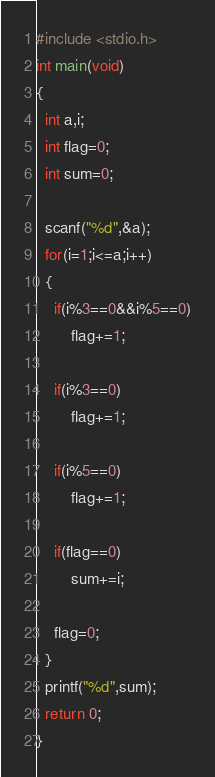<code> <loc_0><loc_0><loc_500><loc_500><_C_>#include <stdio.h>
int main(void)
{
  int a,i;
  int flag=0;
  int sum=0;
    
  scanf("%d",&a);
  for(i=1;i<=a;i++)
  {
    if(i%3==0&&i%5==0)
        flag+=1;
      
    if(i%3==0)
        flag+=1;
      
    if(i%5==0)
        flag+=1;
      
    if(flag==0)
        sum+=i;
      
    flag=0;
  }
  printf("%d",sum);
  return 0;
}</code> 